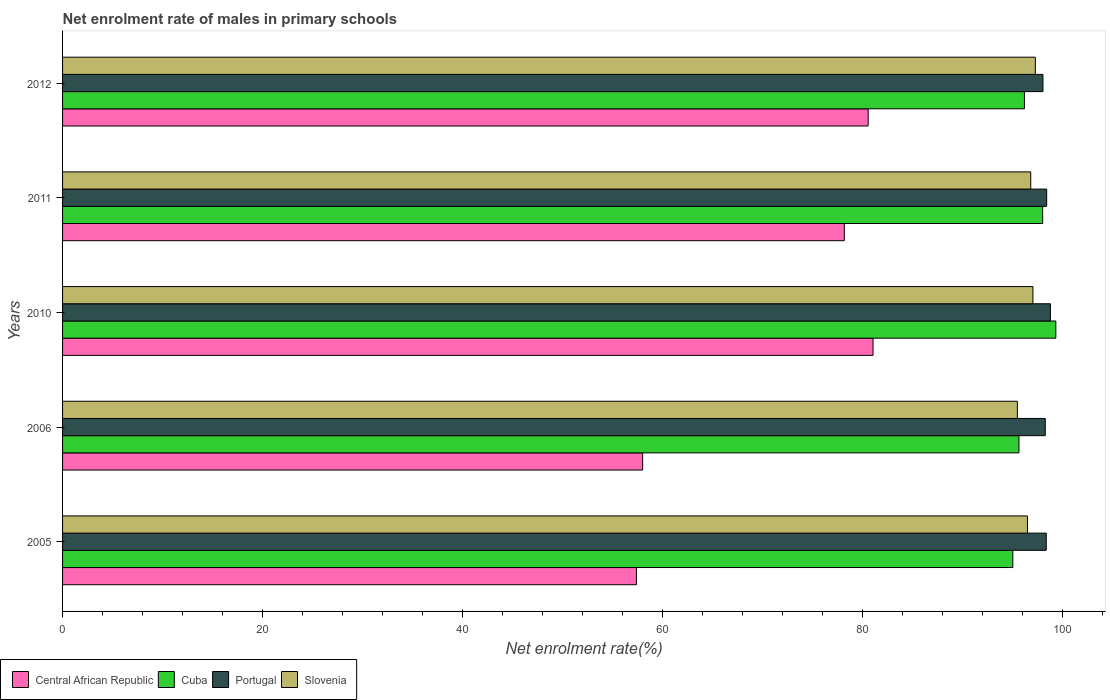How many different coloured bars are there?
Your response must be concise. 4. How many groups of bars are there?
Give a very brief answer. 5. Are the number of bars on each tick of the Y-axis equal?
Give a very brief answer. Yes. How many bars are there on the 1st tick from the bottom?
Keep it short and to the point. 4. In how many cases, is the number of bars for a given year not equal to the number of legend labels?
Keep it short and to the point. 0. What is the net enrolment rate of males in primary schools in Central African Republic in 2010?
Your response must be concise. 81.07. Across all years, what is the maximum net enrolment rate of males in primary schools in Central African Republic?
Give a very brief answer. 81.07. Across all years, what is the minimum net enrolment rate of males in primary schools in Cuba?
Keep it short and to the point. 95.06. What is the total net enrolment rate of males in primary schools in Central African Republic in the graph?
Your answer should be very brief. 355.3. What is the difference between the net enrolment rate of males in primary schools in Portugal in 2006 and that in 2012?
Provide a short and direct response. 0.23. What is the difference between the net enrolment rate of males in primary schools in Slovenia in 2005 and the net enrolment rate of males in primary schools in Cuba in 2012?
Provide a short and direct response. 0.3. What is the average net enrolment rate of males in primary schools in Slovenia per year?
Provide a short and direct response. 96.65. In the year 2010, what is the difference between the net enrolment rate of males in primary schools in Portugal and net enrolment rate of males in primary schools in Slovenia?
Provide a succinct answer. 1.75. In how many years, is the net enrolment rate of males in primary schools in Cuba greater than 64 %?
Ensure brevity in your answer.  5. What is the ratio of the net enrolment rate of males in primary schools in Slovenia in 2010 to that in 2011?
Make the answer very short. 1. Is the net enrolment rate of males in primary schools in Portugal in 2011 less than that in 2012?
Offer a terse response. No. Is the difference between the net enrolment rate of males in primary schools in Portugal in 2005 and 2010 greater than the difference between the net enrolment rate of males in primary schools in Slovenia in 2005 and 2010?
Offer a very short reply. Yes. What is the difference between the highest and the second highest net enrolment rate of males in primary schools in Cuba?
Provide a succinct answer. 1.32. What is the difference between the highest and the lowest net enrolment rate of males in primary schools in Central African Republic?
Make the answer very short. 23.67. Is it the case that in every year, the sum of the net enrolment rate of males in primary schools in Central African Republic and net enrolment rate of males in primary schools in Portugal is greater than the sum of net enrolment rate of males in primary schools in Cuba and net enrolment rate of males in primary schools in Slovenia?
Your answer should be compact. No. What does the 3rd bar from the top in 2006 represents?
Provide a succinct answer. Cuba. Are all the bars in the graph horizontal?
Make the answer very short. Yes. How many years are there in the graph?
Your answer should be compact. 5. Are the values on the major ticks of X-axis written in scientific E-notation?
Keep it short and to the point. No. Does the graph contain grids?
Your answer should be compact. No. Where does the legend appear in the graph?
Provide a short and direct response. Bottom left. How many legend labels are there?
Give a very brief answer. 4. What is the title of the graph?
Ensure brevity in your answer.  Net enrolment rate of males in primary schools. What is the label or title of the X-axis?
Your answer should be compact. Net enrolment rate(%). What is the Net enrolment rate(%) of Central African Republic in 2005?
Offer a terse response. 57.41. What is the Net enrolment rate(%) of Cuba in 2005?
Offer a very short reply. 95.06. What is the Net enrolment rate(%) of Portugal in 2005?
Ensure brevity in your answer.  98.4. What is the Net enrolment rate(%) in Slovenia in 2005?
Provide a succinct answer. 96.52. What is the Net enrolment rate(%) of Central African Republic in 2006?
Offer a very short reply. 58.03. What is the Net enrolment rate(%) of Cuba in 2006?
Your answer should be compact. 95.67. What is the Net enrolment rate(%) of Portugal in 2006?
Your answer should be very brief. 98.3. What is the Net enrolment rate(%) of Slovenia in 2006?
Provide a succinct answer. 95.51. What is the Net enrolment rate(%) in Central African Republic in 2010?
Ensure brevity in your answer.  81.07. What is the Net enrolment rate(%) of Cuba in 2010?
Your response must be concise. 99.36. What is the Net enrolment rate(%) in Portugal in 2010?
Give a very brief answer. 98.82. What is the Net enrolment rate(%) in Slovenia in 2010?
Offer a very short reply. 97.07. What is the Net enrolment rate(%) in Central African Republic in 2011?
Keep it short and to the point. 78.2. What is the Net enrolment rate(%) in Cuba in 2011?
Keep it short and to the point. 98.04. What is the Net enrolment rate(%) in Portugal in 2011?
Your answer should be compact. 98.44. What is the Net enrolment rate(%) of Slovenia in 2011?
Give a very brief answer. 96.85. What is the Net enrolment rate(%) of Central African Republic in 2012?
Your answer should be very brief. 80.59. What is the Net enrolment rate(%) of Cuba in 2012?
Give a very brief answer. 96.22. What is the Net enrolment rate(%) in Portugal in 2012?
Ensure brevity in your answer.  98.07. What is the Net enrolment rate(%) in Slovenia in 2012?
Your answer should be very brief. 97.31. Across all years, what is the maximum Net enrolment rate(%) in Central African Republic?
Keep it short and to the point. 81.07. Across all years, what is the maximum Net enrolment rate(%) of Cuba?
Provide a short and direct response. 99.36. Across all years, what is the maximum Net enrolment rate(%) of Portugal?
Your response must be concise. 98.82. Across all years, what is the maximum Net enrolment rate(%) in Slovenia?
Offer a very short reply. 97.31. Across all years, what is the minimum Net enrolment rate(%) of Central African Republic?
Offer a very short reply. 57.41. Across all years, what is the minimum Net enrolment rate(%) of Cuba?
Offer a very short reply. 95.06. Across all years, what is the minimum Net enrolment rate(%) in Portugal?
Provide a succinct answer. 98.07. Across all years, what is the minimum Net enrolment rate(%) in Slovenia?
Make the answer very short. 95.51. What is the total Net enrolment rate(%) of Central African Republic in the graph?
Give a very brief answer. 355.3. What is the total Net enrolment rate(%) of Cuba in the graph?
Offer a terse response. 484.35. What is the total Net enrolment rate(%) of Portugal in the graph?
Keep it short and to the point. 492.04. What is the total Net enrolment rate(%) of Slovenia in the graph?
Your response must be concise. 483.27. What is the difference between the Net enrolment rate(%) in Central African Republic in 2005 and that in 2006?
Make the answer very short. -0.62. What is the difference between the Net enrolment rate(%) in Cuba in 2005 and that in 2006?
Ensure brevity in your answer.  -0.61. What is the difference between the Net enrolment rate(%) of Portugal in 2005 and that in 2006?
Give a very brief answer. 0.1. What is the difference between the Net enrolment rate(%) in Slovenia in 2005 and that in 2006?
Offer a terse response. 1.01. What is the difference between the Net enrolment rate(%) of Central African Republic in 2005 and that in 2010?
Provide a succinct answer. -23.67. What is the difference between the Net enrolment rate(%) in Cuba in 2005 and that in 2010?
Keep it short and to the point. -4.3. What is the difference between the Net enrolment rate(%) in Portugal in 2005 and that in 2010?
Ensure brevity in your answer.  -0.42. What is the difference between the Net enrolment rate(%) of Slovenia in 2005 and that in 2010?
Give a very brief answer. -0.55. What is the difference between the Net enrolment rate(%) in Central African Republic in 2005 and that in 2011?
Provide a short and direct response. -20.79. What is the difference between the Net enrolment rate(%) of Cuba in 2005 and that in 2011?
Your answer should be very brief. -2.98. What is the difference between the Net enrolment rate(%) of Portugal in 2005 and that in 2011?
Your response must be concise. -0.04. What is the difference between the Net enrolment rate(%) of Slovenia in 2005 and that in 2011?
Make the answer very short. -0.33. What is the difference between the Net enrolment rate(%) in Central African Republic in 2005 and that in 2012?
Give a very brief answer. -23.18. What is the difference between the Net enrolment rate(%) in Cuba in 2005 and that in 2012?
Provide a succinct answer. -1.16. What is the difference between the Net enrolment rate(%) of Portugal in 2005 and that in 2012?
Ensure brevity in your answer.  0.33. What is the difference between the Net enrolment rate(%) of Slovenia in 2005 and that in 2012?
Ensure brevity in your answer.  -0.79. What is the difference between the Net enrolment rate(%) of Central African Republic in 2006 and that in 2010?
Your answer should be compact. -23.04. What is the difference between the Net enrolment rate(%) of Cuba in 2006 and that in 2010?
Offer a very short reply. -3.69. What is the difference between the Net enrolment rate(%) of Portugal in 2006 and that in 2010?
Provide a succinct answer. -0.52. What is the difference between the Net enrolment rate(%) of Slovenia in 2006 and that in 2010?
Keep it short and to the point. -1.56. What is the difference between the Net enrolment rate(%) in Central African Republic in 2006 and that in 2011?
Your answer should be very brief. -20.17. What is the difference between the Net enrolment rate(%) of Cuba in 2006 and that in 2011?
Offer a terse response. -2.37. What is the difference between the Net enrolment rate(%) of Portugal in 2006 and that in 2011?
Give a very brief answer. -0.14. What is the difference between the Net enrolment rate(%) in Slovenia in 2006 and that in 2011?
Provide a succinct answer. -1.34. What is the difference between the Net enrolment rate(%) of Central African Republic in 2006 and that in 2012?
Keep it short and to the point. -22.56. What is the difference between the Net enrolment rate(%) in Cuba in 2006 and that in 2012?
Offer a very short reply. -0.55. What is the difference between the Net enrolment rate(%) of Portugal in 2006 and that in 2012?
Offer a very short reply. 0.23. What is the difference between the Net enrolment rate(%) of Slovenia in 2006 and that in 2012?
Your answer should be very brief. -1.8. What is the difference between the Net enrolment rate(%) of Central African Republic in 2010 and that in 2011?
Keep it short and to the point. 2.87. What is the difference between the Net enrolment rate(%) in Cuba in 2010 and that in 2011?
Your answer should be very brief. 1.32. What is the difference between the Net enrolment rate(%) in Portugal in 2010 and that in 2011?
Your answer should be very brief. 0.38. What is the difference between the Net enrolment rate(%) in Slovenia in 2010 and that in 2011?
Provide a succinct answer. 0.22. What is the difference between the Net enrolment rate(%) of Central African Republic in 2010 and that in 2012?
Offer a very short reply. 0.49. What is the difference between the Net enrolment rate(%) in Cuba in 2010 and that in 2012?
Ensure brevity in your answer.  3.14. What is the difference between the Net enrolment rate(%) of Portugal in 2010 and that in 2012?
Your answer should be compact. 0.75. What is the difference between the Net enrolment rate(%) in Slovenia in 2010 and that in 2012?
Make the answer very short. -0.24. What is the difference between the Net enrolment rate(%) in Central African Republic in 2011 and that in 2012?
Your answer should be very brief. -2.38. What is the difference between the Net enrolment rate(%) in Cuba in 2011 and that in 2012?
Provide a short and direct response. 1.82. What is the difference between the Net enrolment rate(%) in Portugal in 2011 and that in 2012?
Ensure brevity in your answer.  0.37. What is the difference between the Net enrolment rate(%) in Slovenia in 2011 and that in 2012?
Offer a very short reply. -0.46. What is the difference between the Net enrolment rate(%) in Central African Republic in 2005 and the Net enrolment rate(%) in Cuba in 2006?
Provide a succinct answer. -38.26. What is the difference between the Net enrolment rate(%) of Central African Republic in 2005 and the Net enrolment rate(%) of Portugal in 2006?
Provide a short and direct response. -40.9. What is the difference between the Net enrolment rate(%) in Central African Republic in 2005 and the Net enrolment rate(%) in Slovenia in 2006?
Ensure brevity in your answer.  -38.11. What is the difference between the Net enrolment rate(%) in Cuba in 2005 and the Net enrolment rate(%) in Portugal in 2006?
Keep it short and to the point. -3.25. What is the difference between the Net enrolment rate(%) in Cuba in 2005 and the Net enrolment rate(%) in Slovenia in 2006?
Ensure brevity in your answer.  -0.46. What is the difference between the Net enrolment rate(%) of Portugal in 2005 and the Net enrolment rate(%) of Slovenia in 2006?
Your answer should be very brief. 2.89. What is the difference between the Net enrolment rate(%) in Central African Republic in 2005 and the Net enrolment rate(%) in Cuba in 2010?
Your answer should be compact. -41.95. What is the difference between the Net enrolment rate(%) of Central African Republic in 2005 and the Net enrolment rate(%) of Portugal in 2010?
Keep it short and to the point. -41.41. What is the difference between the Net enrolment rate(%) of Central African Republic in 2005 and the Net enrolment rate(%) of Slovenia in 2010?
Give a very brief answer. -39.66. What is the difference between the Net enrolment rate(%) in Cuba in 2005 and the Net enrolment rate(%) in Portugal in 2010?
Offer a very short reply. -3.76. What is the difference between the Net enrolment rate(%) of Cuba in 2005 and the Net enrolment rate(%) of Slovenia in 2010?
Provide a succinct answer. -2.01. What is the difference between the Net enrolment rate(%) in Portugal in 2005 and the Net enrolment rate(%) in Slovenia in 2010?
Provide a short and direct response. 1.33. What is the difference between the Net enrolment rate(%) in Central African Republic in 2005 and the Net enrolment rate(%) in Cuba in 2011?
Your answer should be compact. -40.63. What is the difference between the Net enrolment rate(%) in Central African Republic in 2005 and the Net enrolment rate(%) in Portugal in 2011?
Your answer should be very brief. -41.04. What is the difference between the Net enrolment rate(%) in Central African Republic in 2005 and the Net enrolment rate(%) in Slovenia in 2011?
Give a very brief answer. -39.44. What is the difference between the Net enrolment rate(%) of Cuba in 2005 and the Net enrolment rate(%) of Portugal in 2011?
Offer a very short reply. -3.39. What is the difference between the Net enrolment rate(%) in Cuba in 2005 and the Net enrolment rate(%) in Slovenia in 2011?
Ensure brevity in your answer.  -1.79. What is the difference between the Net enrolment rate(%) of Portugal in 2005 and the Net enrolment rate(%) of Slovenia in 2011?
Offer a very short reply. 1.55. What is the difference between the Net enrolment rate(%) of Central African Republic in 2005 and the Net enrolment rate(%) of Cuba in 2012?
Provide a short and direct response. -38.81. What is the difference between the Net enrolment rate(%) of Central African Republic in 2005 and the Net enrolment rate(%) of Portugal in 2012?
Make the answer very short. -40.67. What is the difference between the Net enrolment rate(%) of Central African Republic in 2005 and the Net enrolment rate(%) of Slovenia in 2012?
Give a very brief answer. -39.91. What is the difference between the Net enrolment rate(%) of Cuba in 2005 and the Net enrolment rate(%) of Portugal in 2012?
Your response must be concise. -3.02. What is the difference between the Net enrolment rate(%) of Cuba in 2005 and the Net enrolment rate(%) of Slovenia in 2012?
Your answer should be compact. -2.25. What is the difference between the Net enrolment rate(%) of Portugal in 2005 and the Net enrolment rate(%) of Slovenia in 2012?
Keep it short and to the point. 1.09. What is the difference between the Net enrolment rate(%) in Central African Republic in 2006 and the Net enrolment rate(%) in Cuba in 2010?
Your answer should be very brief. -41.33. What is the difference between the Net enrolment rate(%) in Central African Republic in 2006 and the Net enrolment rate(%) in Portugal in 2010?
Make the answer very short. -40.79. What is the difference between the Net enrolment rate(%) in Central African Republic in 2006 and the Net enrolment rate(%) in Slovenia in 2010?
Provide a succinct answer. -39.04. What is the difference between the Net enrolment rate(%) of Cuba in 2006 and the Net enrolment rate(%) of Portugal in 2010?
Your answer should be compact. -3.15. What is the difference between the Net enrolment rate(%) in Cuba in 2006 and the Net enrolment rate(%) in Slovenia in 2010?
Make the answer very short. -1.4. What is the difference between the Net enrolment rate(%) of Portugal in 2006 and the Net enrolment rate(%) of Slovenia in 2010?
Provide a succinct answer. 1.23. What is the difference between the Net enrolment rate(%) of Central African Republic in 2006 and the Net enrolment rate(%) of Cuba in 2011?
Your answer should be very brief. -40.01. What is the difference between the Net enrolment rate(%) of Central African Republic in 2006 and the Net enrolment rate(%) of Portugal in 2011?
Your answer should be compact. -40.41. What is the difference between the Net enrolment rate(%) of Central African Republic in 2006 and the Net enrolment rate(%) of Slovenia in 2011?
Your response must be concise. -38.82. What is the difference between the Net enrolment rate(%) of Cuba in 2006 and the Net enrolment rate(%) of Portugal in 2011?
Provide a succinct answer. -2.77. What is the difference between the Net enrolment rate(%) in Cuba in 2006 and the Net enrolment rate(%) in Slovenia in 2011?
Your answer should be very brief. -1.18. What is the difference between the Net enrolment rate(%) in Portugal in 2006 and the Net enrolment rate(%) in Slovenia in 2011?
Provide a succinct answer. 1.45. What is the difference between the Net enrolment rate(%) of Central African Republic in 2006 and the Net enrolment rate(%) of Cuba in 2012?
Give a very brief answer. -38.19. What is the difference between the Net enrolment rate(%) in Central African Republic in 2006 and the Net enrolment rate(%) in Portugal in 2012?
Give a very brief answer. -40.04. What is the difference between the Net enrolment rate(%) in Central African Republic in 2006 and the Net enrolment rate(%) in Slovenia in 2012?
Keep it short and to the point. -39.28. What is the difference between the Net enrolment rate(%) in Cuba in 2006 and the Net enrolment rate(%) in Portugal in 2012?
Keep it short and to the point. -2.4. What is the difference between the Net enrolment rate(%) in Cuba in 2006 and the Net enrolment rate(%) in Slovenia in 2012?
Make the answer very short. -1.64. What is the difference between the Net enrolment rate(%) of Portugal in 2006 and the Net enrolment rate(%) of Slovenia in 2012?
Your answer should be very brief. 0.99. What is the difference between the Net enrolment rate(%) of Central African Republic in 2010 and the Net enrolment rate(%) of Cuba in 2011?
Provide a short and direct response. -16.97. What is the difference between the Net enrolment rate(%) in Central African Republic in 2010 and the Net enrolment rate(%) in Portugal in 2011?
Keep it short and to the point. -17.37. What is the difference between the Net enrolment rate(%) of Central African Republic in 2010 and the Net enrolment rate(%) of Slovenia in 2011?
Your answer should be very brief. -15.78. What is the difference between the Net enrolment rate(%) in Cuba in 2010 and the Net enrolment rate(%) in Portugal in 2011?
Offer a terse response. 0.92. What is the difference between the Net enrolment rate(%) of Cuba in 2010 and the Net enrolment rate(%) of Slovenia in 2011?
Ensure brevity in your answer.  2.51. What is the difference between the Net enrolment rate(%) of Portugal in 2010 and the Net enrolment rate(%) of Slovenia in 2011?
Provide a short and direct response. 1.97. What is the difference between the Net enrolment rate(%) in Central African Republic in 2010 and the Net enrolment rate(%) in Cuba in 2012?
Make the answer very short. -15.14. What is the difference between the Net enrolment rate(%) of Central African Republic in 2010 and the Net enrolment rate(%) of Portugal in 2012?
Offer a terse response. -17. What is the difference between the Net enrolment rate(%) of Central African Republic in 2010 and the Net enrolment rate(%) of Slovenia in 2012?
Keep it short and to the point. -16.24. What is the difference between the Net enrolment rate(%) of Cuba in 2010 and the Net enrolment rate(%) of Portugal in 2012?
Give a very brief answer. 1.29. What is the difference between the Net enrolment rate(%) of Cuba in 2010 and the Net enrolment rate(%) of Slovenia in 2012?
Offer a terse response. 2.05. What is the difference between the Net enrolment rate(%) in Portugal in 2010 and the Net enrolment rate(%) in Slovenia in 2012?
Provide a succinct answer. 1.51. What is the difference between the Net enrolment rate(%) in Central African Republic in 2011 and the Net enrolment rate(%) in Cuba in 2012?
Keep it short and to the point. -18.02. What is the difference between the Net enrolment rate(%) of Central African Republic in 2011 and the Net enrolment rate(%) of Portugal in 2012?
Give a very brief answer. -19.87. What is the difference between the Net enrolment rate(%) in Central African Republic in 2011 and the Net enrolment rate(%) in Slovenia in 2012?
Provide a short and direct response. -19.11. What is the difference between the Net enrolment rate(%) of Cuba in 2011 and the Net enrolment rate(%) of Portugal in 2012?
Ensure brevity in your answer.  -0.03. What is the difference between the Net enrolment rate(%) of Cuba in 2011 and the Net enrolment rate(%) of Slovenia in 2012?
Provide a succinct answer. 0.73. What is the difference between the Net enrolment rate(%) of Portugal in 2011 and the Net enrolment rate(%) of Slovenia in 2012?
Offer a very short reply. 1.13. What is the average Net enrolment rate(%) of Central African Republic per year?
Provide a short and direct response. 71.06. What is the average Net enrolment rate(%) of Cuba per year?
Keep it short and to the point. 96.87. What is the average Net enrolment rate(%) in Portugal per year?
Provide a short and direct response. 98.41. What is the average Net enrolment rate(%) of Slovenia per year?
Offer a very short reply. 96.65. In the year 2005, what is the difference between the Net enrolment rate(%) of Central African Republic and Net enrolment rate(%) of Cuba?
Offer a very short reply. -37.65. In the year 2005, what is the difference between the Net enrolment rate(%) in Central African Republic and Net enrolment rate(%) in Portugal?
Your response must be concise. -41. In the year 2005, what is the difference between the Net enrolment rate(%) of Central African Republic and Net enrolment rate(%) of Slovenia?
Ensure brevity in your answer.  -39.11. In the year 2005, what is the difference between the Net enrolment rate(%) in Cuba and Net enrolment rate(%) in Portugal?
Your response must be concise. -3.34. In the year 2005, what is the difference between the Net enrolment rate(%) in Cuba and Net enrolment rate(%) in Slovenia?
Give a very brief answer. -1.46. In the year 2005, what is the difference between the Net enrolment rate(%) in Portugal and Net enrolment rate(%) in Slovenia?
Offer a very short reply. 1.88. In the year 2006, what is the difference between the Net enrolment rate(%) in Central African Republic and Net enrolment rate(%) in Cuba?
Provide a short and direct response. -37.64. In the year 2006, what is the difference between the Net enrolment rate(%) of Central African Republic and Net enrolment rate(%) of Portugal?
Your answer should be very brief. -40.27. In the year 2006, what is the difference between the Net enrolment rate(%) in Central African Republic and Net enrolment rate(%) in Slovenia?
Offer a very short reply. -37.48. In the year 2006, what is the difference between the Net enrolment rate(%) of Cuba and Net enrolment rate(%) of Portugal?
Make the answer very short. -2.63. In the year 2006, what is the difference between the Net enrolment rate(%) of Cuba and Net enrolment rate(%) of Slovenia?
Keep it short and to the point. 0.16. In the year 2006, what is the difference between the Net enrolment rate(%) of Portugal and Net enrolment rate(%) of Slovenia?
Offer a very short reply. 2.79. In the year 2010, what is the difference between the Net enrolment rate(%) in Central African Republic and Net enrolment rate(%) in Cuba?
Keep it short and to the point. -18.29. In the year 2010, what is the difference between the Net enrolment rate(%) in Central African Republic and Net enrolment rate(%) in Portugal?
Offer a terse response. -17.75. In the year 2010, what is the difference between the Net enrolment rate(%) of Central African Republic and Net enrolment rate(%) of Slovenia?
Your answer should be very brief. -16. In the year 2010, what is the difference between the Net enrolment rate(%) in Cuba and Net enrolment rate(%) in Portugal?
Your response must be concise. 0.54. In the year 2010, what is the difference between the Net enrolment rate(%) in Cuba and Net enrolment rate(%) in Slovenia?
Give a very brief answer. 2.29. In the year 2010, what is the difference between the Net enrolment rate(%) of Portugal and Net enrolment rate(%) of Slovenia?
Keep it short and to the point. 1.75. In the year 2011, what is the difference between the Net enrolment rate(%) of Central African Republic and Net enrolment rate(%) of Cuba?
Your answer should be very brief. -19.84. In the year 2011, what is the difference between the Net enrolment rate(%) of Central African Republic and Net enrolment rate(%) of Portugal?
Ensure brevity in your answer.  -20.24. In the year 2011, what is the difference between the Net enrolment rate(%) of Central African Republic and Net enrolment rate(%) of Slovenia?
Offer a very short reply. -18.65. In the year 2011, what is the difference between the Net enrolment rate(%) of Cuba and Net enrolment rate(%) of Portugal?
Your response must be concise. -0.4. In the year 2011, what is the difference between the Net enrolment rate(%) of Cuba and Net enrolment rate(%) of Slovenia?
Give a very brief answer. 1.19. In the year 2011, what is the difference between the Net enrolment rate(%) in Portugal and Net enrolment rate(%) in Slovenia?
Offer a terse response. 1.59. In the year 2012, what is the difference between the Net enrolment rate(%) of Central African Republic and Net enrolment rate(%) of Cuba?
Your response must be concise. -15.63. In the year 2012, what is the difference between the Net enrolment rate(%) of Central African Republic and Net enrolment rate(%) of Portugal?
Your answer should be very brief. -17.49. In the year 2012, what is the difference between the Net enrolment rate(%) of Central African Republic and Net enrolment rate(%) of Slovenia?
Offer a terse response. -16.73. In the year 2012, what is the difference between the Net enrolment rate(%) of Cuba and Net enrolment rate(%) of Portugal?
Offer a very short reply. -1.86. In the year 2012, what is the difference between the Net enrolment rate(%) in Cuba and Net enrolment rate(%) in Slovenia?
Your response must be concise. -1.09. In the year 2012, what is the difference between the Net enrolment rate(%) of Portugal and Net enrolment rate(%) of Slovenia?
Make the answer very short. 0.76. What is the ratio of the Net enrolment rate(%) in Central African Republic in 2005 to that in 2006?
Your response must be concise. 0.99. What is the ratio of the Net enrolment rate(%) in Cuba in 2005 to that in 2006?
Your response must be concise. 0.99. What is the ratio of the Net enrolment rate(%) of Portugal in 2005 to that in 2006?
Your answer should be very brief. 1. What is the ratio of the Net enrolment rate(%) in Slovenia in 2005 to that in 2006?
Make the answer very short. 1.01. What is the ratio of the Net enrolment rate(%) of Central African Republic in 2005 to that in 2010?
Make the answer very short. 0.71. What is the ratio of the Net enrolment rate(%) in Cuba in 2005 to that in 2010?
Provide a succinct answer. 0.96. What is the ratio of the Net enrolment rate(%) of Central African Republic in 2005 to that in 2011?
Your response must be concise. 0.73. What is the ratio of the Net enrolment rate(%) of Cuba in 2005 to that in 2011?
Offer a terse response. 0.97. What is the ratio of the Net enrolment rate(%) in Portugal in 2005 to that in 2011?
Provide a short and direct response. 1. What is the ratio of the Net enrolment rate(%) in Slovenia in 2005 to that in 2011?
Make the answer very short. 1. What is the ratio of the Net enrolment rate(%) in Central African Republic in 2005 to that in 2012?
Keep it short and to the point. 0.71. What is the ratio of the Net enrolment rate(%) of Cuba in 2005 to that in 2012?
Your response must be concise. 0.99. What is the ratio of the Net enrolment rate(%) of Central African Republic in 2006 to that in 2010?
Provide a short and direct response. 0.72. What is the ratio of the Net enrolment rate(%) of Cuba in 2006 to that in 2010?
Offer a very short reply. 0.96. What is the ratio of the Net enrolment rate(%) in Portugal in 2006 to that in 2010?
Offer a terse response. 0.99. What is the ratio of the Net enrolment rate(%) of Central African Republic in 2006 to that in 2011?
Provide a succinct answer. 0.74. What is the ratio of the Net enrolment rate(%) of Cuba in 2006 to that in 2011?
Make the answer very short. 0.98. What is the ratio of the Net enrolment rate(%) of Portugal in 2006 to that in 2011?
Give a very brief answer. 1. What is the ratio of the Net enrolment rate(%) in Slovenia in 2006 to that in 2011?
Keep it short and to the point. 0.99. What is the ratio of the Net enrolment rate(%) in Central African Republic in 2006 to that in 2012?
Provide a succinct answer. 0.72. What is the ratio of the Net enrolment rate(%) of Cuba in 2006 to that in 2012?
Offer a terse response. 0.99. What is the ratio of the Net enrolment rate(%) of Portugal in 2006 to that in 2012?
Offer a very short reply. 1. What is the ratio of the Net enrolment rate(%) in Slovenia in 2006 to that in 2012?
Offer a terse response. 0.98. What is the ratio of the Net enrolment rate(%) in Central African Republic in 2010 to that in 2011?
Your response must be concise. 1.04. What is the ratio of the Net enrolment rate(%) of Cuba in 2010 to that in 2011?
Keep it short and to the point. 1.01. What is the ratio of the Net enrolment rate(%) of Cuba in 2010 to that in 2012?
Keep it short and to the point. 1.03. What is the ratio of the Net enrolment rate(%) in Portugal in 2010 to that in 2012?
Offer a very short reply. 1.01. What is the ratio of the Net enrolment rate(%) of Slovenia in 2010 to that in 2012?
Provide a short and direct response. 1. What is the ratio of the Net enrolment rate(%) of Central African Republic in 2011 to that in 2012?
Make the answer very short. 0.97. What is the ratio of the Net enrolment rate(%) in Portugal in 2011 to that in 2012?
Keep it short and to the point. 1. What is the difference between the highest and the second highest Net enrolment rate(%) in Central African Republic?
Your response must be concise. 0.49. What is the difference between the highest and the second highest Net enrolment rate(%) of Cuba?
Your answer should be compact. 1.32. What is the difference between the highest and the second highest Net enrolment rate(%) in Portugal?
Your answer should be compact. 0.38. What is the difference between the highest and the second highest Net enrolment rate(%) of Slovenia?
Provide a short and direct response. 0.24. What is the difference between the highest and the lowest Net enrolment rate(%) in Central African Republic?
Keep it short and to the point. 23.67. What is the difference between the highest and the lowest Net enrolment rate(%) in Cuba?
Offer a very short reply. 4.3. What is the difference between the highest and the lowest Net enrolment rate(%) in Portugal?
Offer a very short reply. 0.75. What is the difference between the highest and the lowest Net enrolment rate(%) of Slovenia?
Make the answer very short. 1.8. 